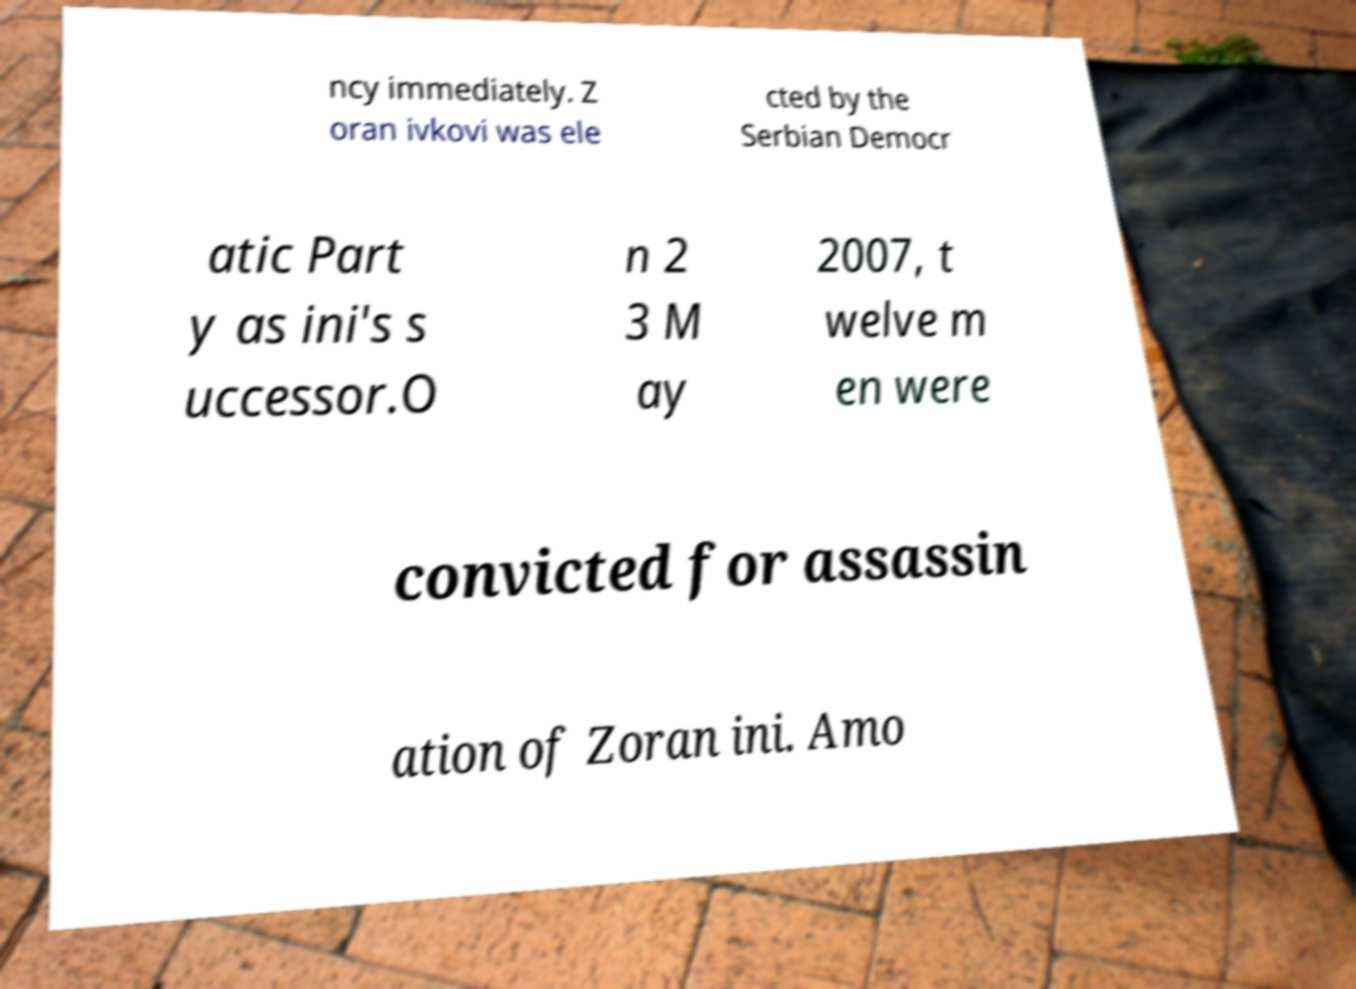Can you accurately transcribe the text from the provided image for me? ncy immediately. Z oran ivkovi was ele cted by the Serbian Democr atic Part y as ini's s uccessor.O n 2 3 M ay 2007, t welve m en were convicted for assassin ation of Zoran ini. Amo 